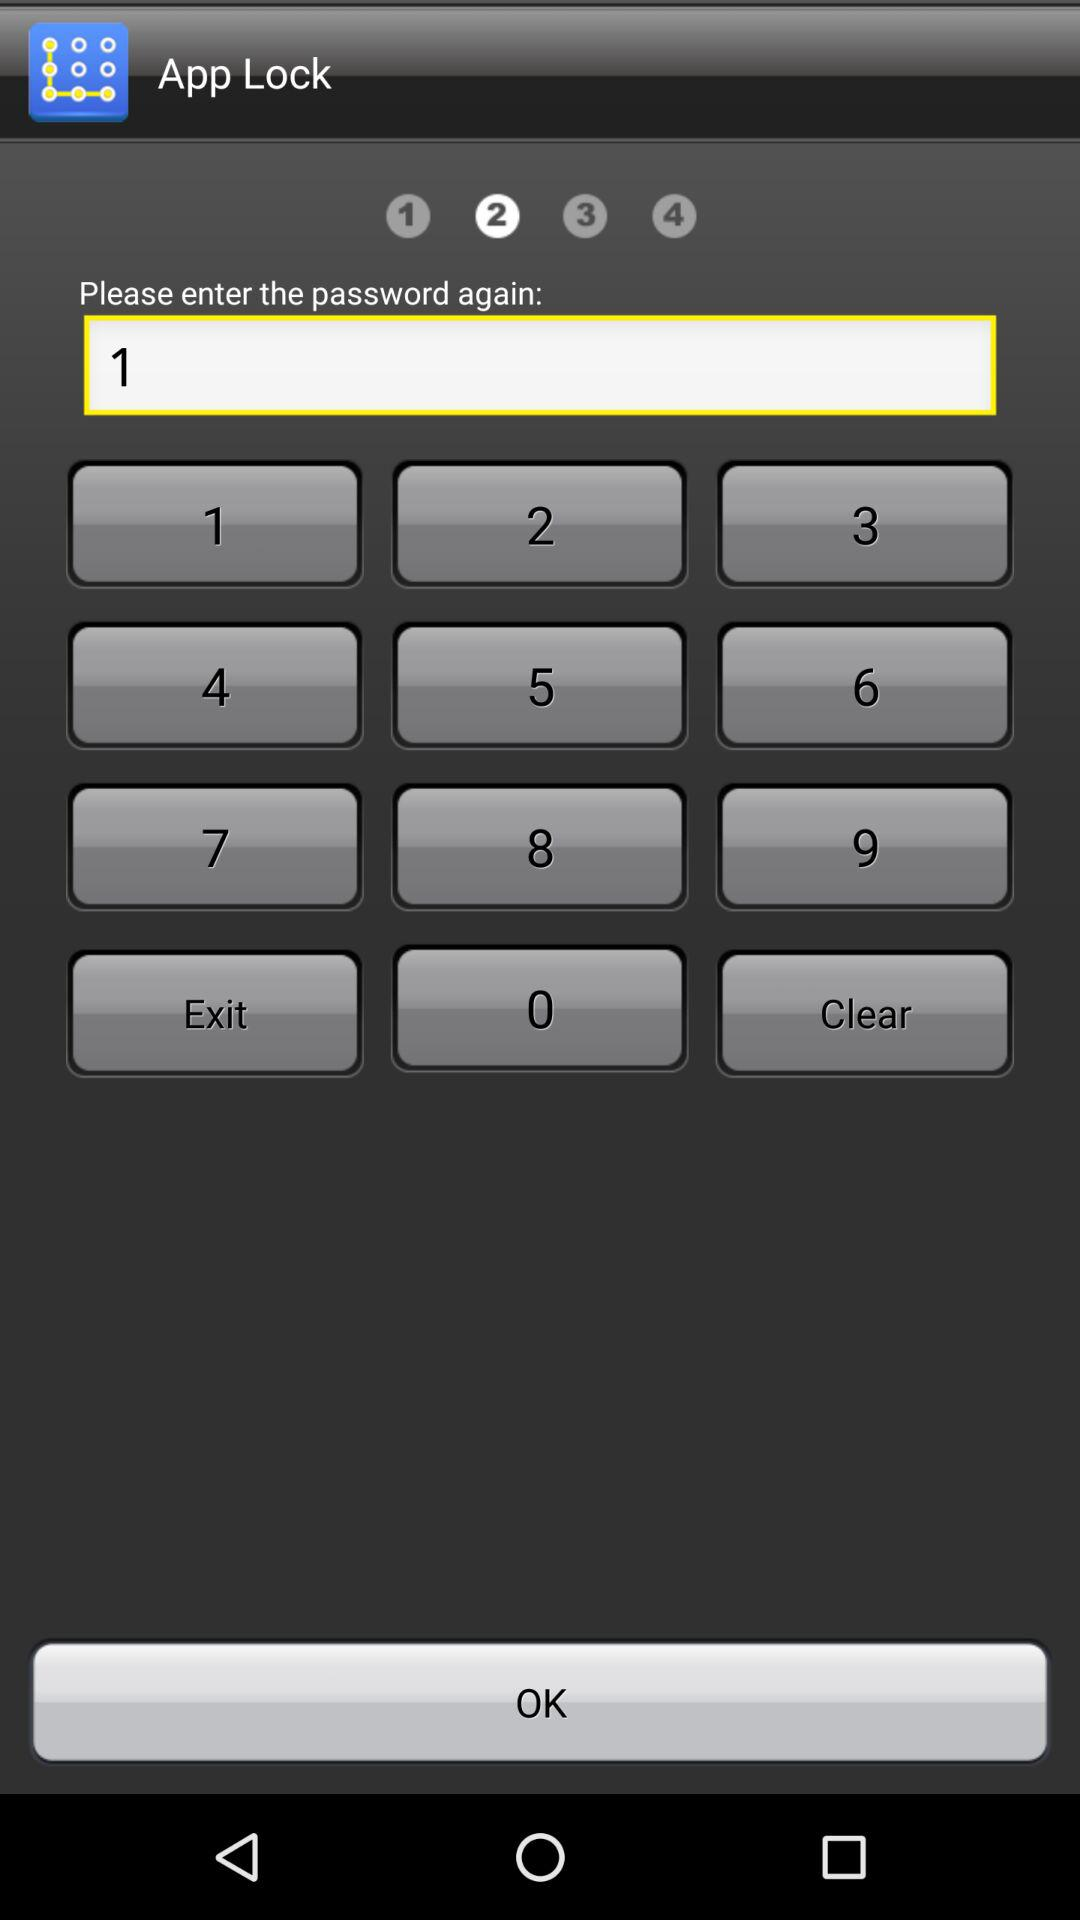What is the password?
When the provided information is insufficient, respond with <no answer>. <no answer> 